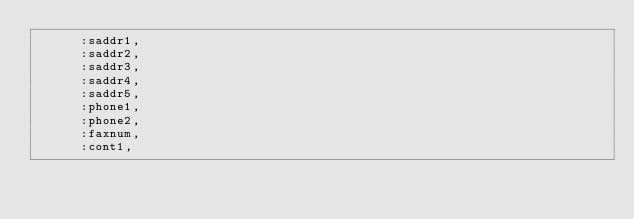Convert code to text. <code><loc_0><loc_0><loc_500><loc_500><_Ruby_>      :saddr1,
      :saddr2,
      :saddr3,
      :saddr4,
      :saddr5,
      :phone1,
      :phone2,
      :faxnum,
      :cont1,</code> 